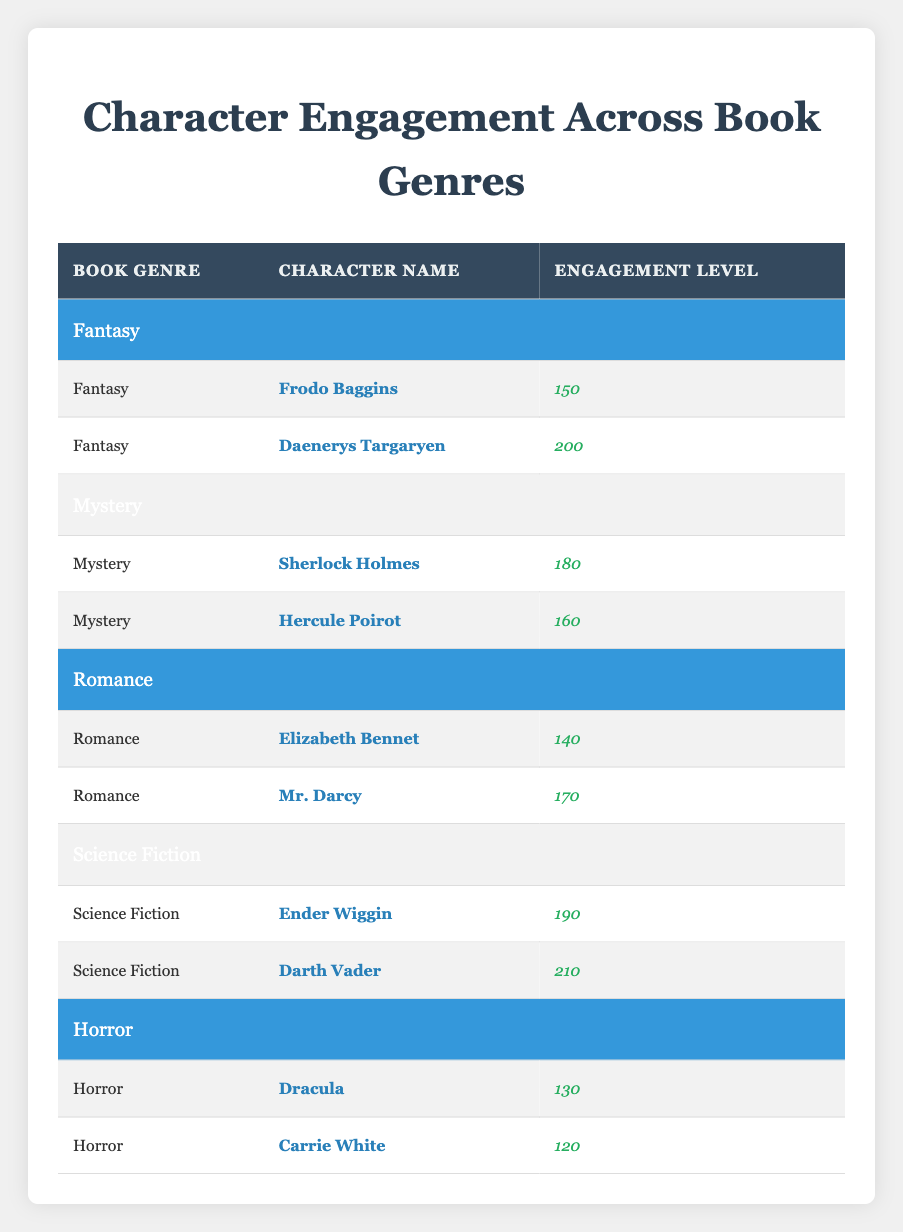What is the highest engagement level among all characters? By examining the engagement levels across all characters in the table, Darth Vader has the highest engagement level with 210. This is directly observed in the Science Fiction section of the table.
Answer: 210 Which character has the lowest engagement level in the Horror genre? In the Horror section of the table, Carrie White has the lowest engagement level with 120, which can be easily identified from the values listed under that genre.
Answer: 120 What is the average engagement level for characters in the Fantasy genre? There are two characters in the Fantasy genre: Frodo Baggins with 150 and Daenerys Targaryen with 200. The average is calculated by summing these values (150 + 200 = 350) and dividing by 2, resulting in an average engagement level of 175.
Answer: 175 Is there a character in the Romance genre that has an engagement level greater than 160? By checking the Romance section, Mr. Darcy has an engagement level of 170, which is indeed greater than 160, while Elizabeth Bennet's engagement level is 140. Thus, the statement is true.
Answer: Yes Which genre has the second highest average engagement level? The average engagement levels of each genre are: Fantasy (175), Mystery (170), Romance (155), Science Fiction (200), and Horror (125). The second highest average is for the Mystery genre, calculated by averaging Sherlock Holmes and Hercule Poirot's engagement levels ((180 + 160) / 2 = 170).
Answer: Mystery 